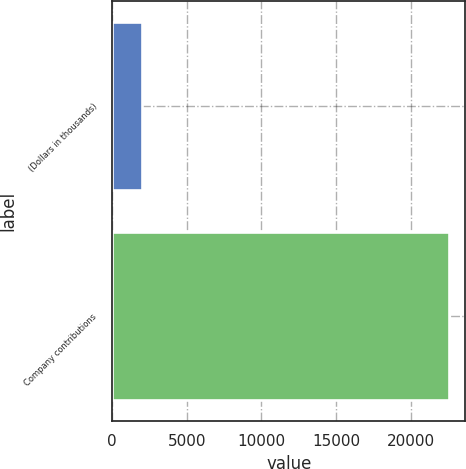Convert chart. <chart><loc_0><loc_0><loc_500><loc_500><bar_chart><fcel>(Dollars in thousands)<fcel>Company contributions<nl><fcel>2013<fcel>22536<nl></chart> 